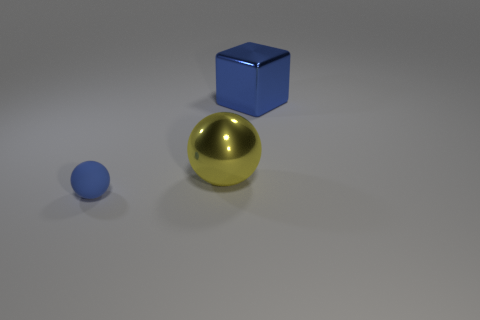The ball that is behind the sphere left of the ball that is to the right of the small matte thing is what color? yellow 